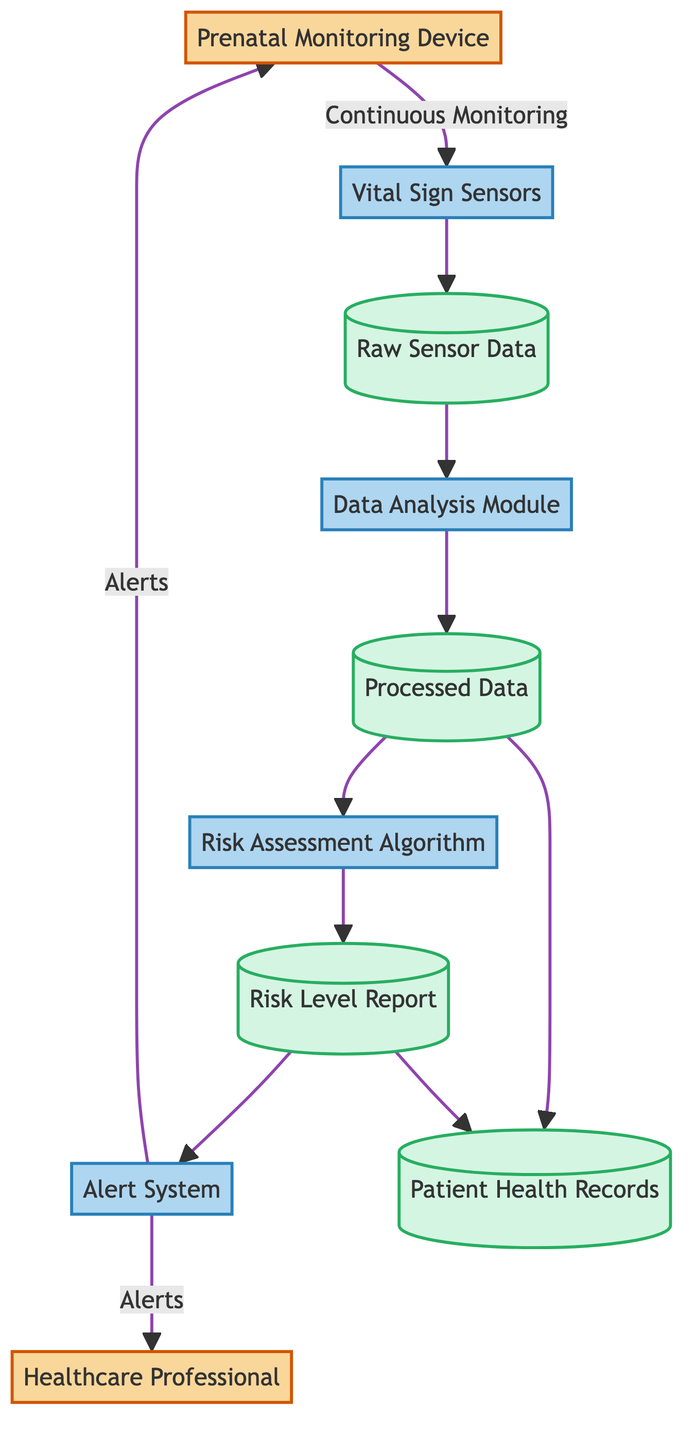What is the role of the Prenatal Monitoring Device? The Prenatal Monitoring Device is an External Entity in the diagram, utilized by the pregnant woman to monitor vital signs and other important parameters.
Answer: External Entity How many processes are depicted in the diagram? The diagram features five processes: Vital Sign Sensors, Data Analysis Module, Risk Assessment Algorithm, and Alert System. Counting these gives a total of four processes.
Answer: Four What data store is used to hold raw sensor data? The raw sensor data is stored in the entity labeled "Raw Sensor Data," which is categorized as a Data Store.
Answer: Raw Sensor Data Which process directly follows the Data Analysis Module? The process that follows the Data Analysis Module in the diagram is the Risk Assessment Algorithm. This can be seen from the flow pointing from the Data Analysis to Risk Assessment.
Answer: Risk Assessment Algorithm What type of alerts are sent to healthcare professionals? Alerts sent to healthcare professionals are categorized as "Alerts," which are messages indicating detected risks or anomalies in the pregnancy.
Answer: Alerts From which node is the Continuous Monitoring Data Flow initiated? The Continuous Monitoring Data Flow is initiated from the Prenatal Monitoring Device, indicating the start of data flow to the sensors.
Answer: Prenatal Monitoring Device Which component assesses the risk level of the pregnancy? The component that assesses the risk level of the pregnancy is the "Risk Assessment Algorithm," as indicated by its direct processing role in the flow.
Answer: Risk Assessment Algorithm What is the relationship between Processed Data and Patient Health Records? Processed Data feeds into Patient Health Records, as shown by the flow where after being processed, the data is stored in the patient's health records.
Answer: Processed Data feeds into Patient Health Records Which two entities receive alerts from the Alert System? The Alert System delivers alerts to both the Healthcare Professional and the Prenatal Monitoring Device. This relationship is shown by the outgoing flows from the Alert System.
Answer: Healthcare Professional and Prenatal Monitoring Device 